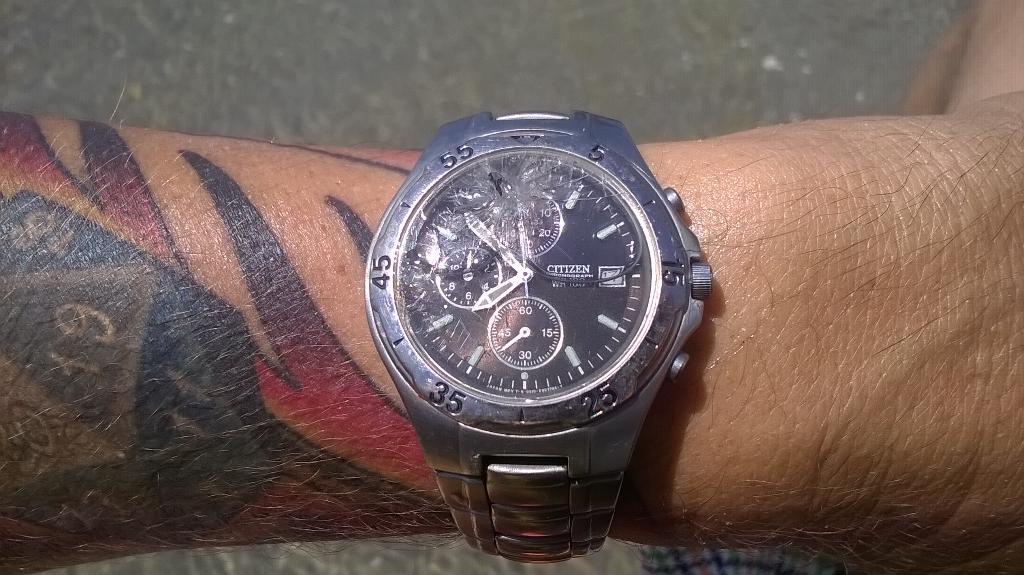What time is it?
Provide a short and direct response. 7:53. What number is on the bottom left in the outer ring?
Your answer should be very brief. 35. 